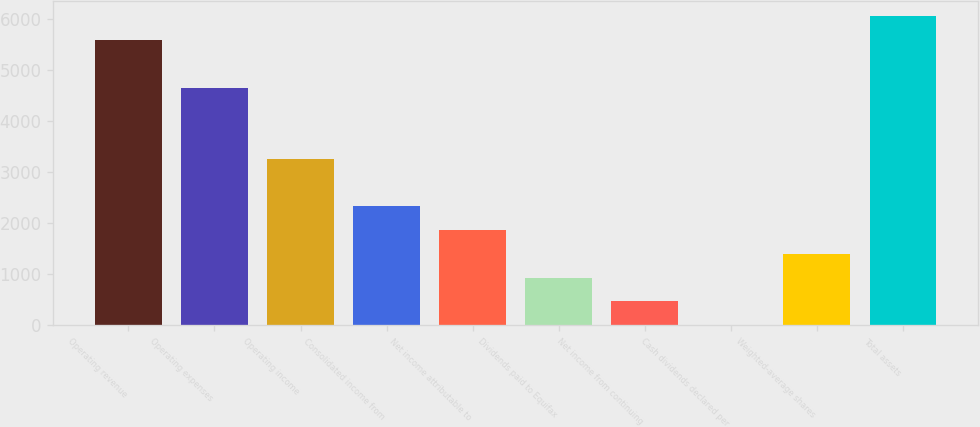Convert chart to OTSL. <chart><loc_0><loc_0><loc_500><loc_500><bar_chart><fcel>Operating revenue<fcel>Operating expenses<fcel>Operating income<fcel>Consolidated income from<fcel>Net income attributable to<fcel>Dividends paid to Equifax<fcel>Net income from continuing<fcel>Cash dividends declared per<fcel>Weighted-average shares<fcel>Total assets<nl><fcel>5593<fcel>4661<fcel>3263<fcel>2331<fcel>1865<fcel>933<fcel>467<fcel>1<fcel>1399<fcel>6059<nl></chart> 